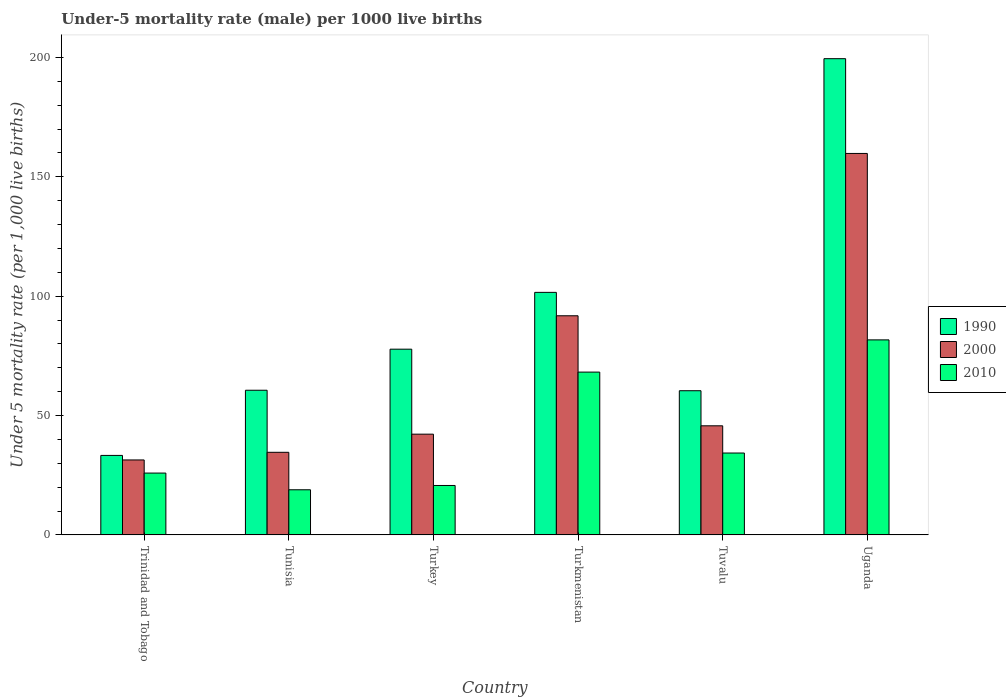How many bars are there on the 5th tick from the left?
Offer a terse response. 3. How many bars are there on the 6th tick from the right?
Provide a short and direct response. 3. What is the label of the 4th group of bars from the left?
Offer a terse response. Turkmenistan. What is the under-five mortality rate in 2000 in Tuvalu?
Give a very brief answer. 45.7. Across all countries, what is the maximum under-five mortality rate in 2010?
Your response must be concise. 81.7. Across all countries, what is the minimum under-five mortality rate in 2010?
Make the answer very short. 18.9. In which country was the under-five mortality rate in 2010 maximum?
Offer a very short reply. Uganda. In which country was the under-five mortality rate in 1990 minimum?
Your answer should be very brief. Trinidad and Tobago. What is the total under-five mortality rate in 2000 in the graph?
Offer a very short reply. 405.5. What is the difference between the under-five mortality rate in 1990 in Turkmenistan and that in Tuvalu?
Provide a short and direct response. 41.2. What is the difference between the under-five mortality rate in 2000 in Trinidad and Tobago and the under-five mortality rate in 1990 in Turkey?
Ensure brevity in your answer.  -46.4. What is the average under-five mortality rate in 2010 per country?
Provide a succinct answer. 41.62. What is the difference between the under-five mortality rate of/in 1990 and under-five mortality rate of/in 2000 in Uganda?
Provide a short and direct response. 39.7. What is the ratio of the under-five mortality rate in 2000 in Turkey to that in Tuvalu?
Your response must be concise. 0.92. Is the under-five mortality rate in 2000 in Tunisia less than that in Turkmenistan?
Your response must be concise. Yes. Is the difference between the under-five mortality rate in 1990 in Turkmenistan and Tuvalu greater than the difference between the under-five mortality rate in 2000 in Turkmenistan and Tuvalu?
Give a very brief answer. No. What is the difference between the highest and the second highest under-five mortality rate in 2000?
Make the answer very short. 46.1. What is the difference between the highest and the lowest under-five mortality rate in 2010?
Offer a terse response. 62.8. Is the sum of the under-five mortality rate in 2000 in Tuvalu and Uganda greater than the maximum under-five mortality rate in 1990 across all countries?
Offer a very short reply. Yes. What does the 1st bar from the right in Tunisia represents?
Ensure brevity in your answer.  2010. Are all the bars in the graph horizontal?
Keep it short and to the point. No. How many countries are there in the graph?
Give a very brief answer. 6. Does the graph contain any zero values?
Provide a succinct answer. No. How many legend labels are there?
Give a very brief answer. 3. What is the title of the graph?
Give a very brief answer. Under-5 mortality rate (male) per 1000 live births. What is the label or title of the X-axis?
Your answer should be very brief. Country. What is the label or title of the Y-axis?
Make the answer very short. Under 5 mortality rate (per 1,0 live births). What is the Under 5 mortality rate (per 1,000 live births) of 1990 in Trinidad and Tobago?
Keep it short and to the point. 33.3. What is the Under 5 mortality rate (per 1,000 live births) in 2000 in Trinidad and Tobago?
Make the answer very short. 31.4. What is the Under 5 mortality rate (per 1,000 live births) of 2010 in Trinidad and Tobago?
Your answer should be compact. 25.9. What is the Under 5 mortality rate (per 1,000 live births) of 1990 in Tunisia?
Your answer should be very brief. 60.6. What is the Under 5 mortality rate (per 1,000 live births) of 2000 in Tunisia?
Give a very brief answer. 34.6. What is the Under 5 mortality rate (per 1,000 live births) in 1990 in Turkey?
Make the answer very short. 77.8. What is the Under 5 mortality rate (per 1,000 live births) of 2000 in Turkey?
Ensure brevity in your answer.  42.2. What is the Under 5 mortality rate (per 1,000 live births) of 2010 in Turkey?
Your response must be concise. 20.7. What is the Under 5 mortality rate (per 1,000 live births) in 1990 in Turkmenistan?
Your answer should be very brief. 101.6. What is the Under 5 mortality rate (per 1,000 live births) in 2000 in Turkmenistan?
Make the answer very short. 91.8. What is the Under 5 mortality rate (per 1,000 live births) of 2010 in Turkmenistan?
Your response must be concise. 68.2. What is the Under 5 mortality rate (per 1,000 live births) in 1990 in Tuvalu?
Give a very brief answer. 60.4. What is the Under 5 mortality rate (per 1,000 live births) in 2000 in Tuvalu?
Your response must be concise. 45.7. What is the Under 5 mortality rate (per 1,000 live births) in 2010 in Tuvalu?
Your answer should be very brief. 34.3. What is the Under 5 mortality rate (per 1,000 live births) in 1990 in Uganda?
Your response must be concise. 199.5. What is the Under 5 mortality rate (per 1,000 live births) of 2000 in Uganda?
Make the answer very short. 159.8. What is the Under 5 mortality rate (per 1,000 live births) in 2010 in Uganda?
Provide a succinct answer. 81.7. Across all countries, what is the maximum Under 5 mortality rate (per 1,000 live births) of 1990?
Provide a short and direct response. 199.5. Across all countries, what is the maximum Under 5 mortality rate (per 1,000 live births) in 2000?
Offer a very short reply. 159.8. Across all countries, what is the maximum Under 5 mortality rate (per 1,000 live births) in 2010?
Provide a succinct answer. 81.7. Across all countries, what is the minimum Under 5 mortality rate (per 1,000 live births) in 1990?
Provide a succinct answer. 33.3. Across all countries, what is the minimum Under 5 mortality rate (per 1,000 live births) of 2000?
Make the answer very short. 31.4. What is the total Under 5 mortality rate (per 1,000 live births) of 1990 in the graph?
Your response must be concise. 533.2. What is the total Under 5 mortality rate (per 1,000 live births) of 2000 in the graph?
Provide a short and direct response. 405.5. What is the total Under 5 mortality rate (per 1,000 live births) in 2010 in the graph?
Ensure brevity in your answer.  249.7. What is the difference between the Under 5 mortality rate (per 1,000 live births) in 1990 in Trinidad and Tobago and that in Tunisia?
Offer a terse response. -27.3. What is the difference between the Under 5 mortality rate (per 1,000 live births) in 2000 in Trinidad and Tobago and that in Tunisia?
Give a very brief answer. -3.2. What is the difference between the Under 5 mortality rate (per 1,000 live births) of 1990 in Trinidad and Tobago and that in Turkey?
Your response must be concise. -44.5. What is the difference between the Under 5 mortality rate (per 1,000 live births) of 1990 in Trinidad and Tobago and that in Turkmenistan?
Your response must be concise. -68.3. What is the difference between the Under 5 mortality rate (per 1,000 live births) in 2000 in Trinidad and Tobago and that in Turkmenistan?
Ensure brevity in your answer.  -60.4. What is the difference between the Under 5 mortality rate (per 1,000 live births) of 2010 in Trinidad and Tobago and that in Turkmenistan?
Keep it short and to the point. -42.3. What is the difference between the Under 5 mortality rate (per 1,000 live births) in 1990 in Trinidad and Tobago and that in Tuvalu?
Provide a succinct answer. -27.1. What is the difference between the Under 5 mortality rate (per 1,000 live births) in 2000 in Trinidad and Tobago and that in Tuvalu?
Your response must be concise. -14.3. What is the difference between the Under 5 mortality rate (per 1,000 live births) in 2010 in Trinidad and Tobago and that in Tuvalu?
Your answer should be compact. -8.4. What is the difference between the Under 5 mortality rate (per 1,000 live births) of 1990 in Trinidad and Tobago and that in Uganda?
Make the answer very short. -166.2. What is the difference between the Under 5 mortality rate (per 1,000 live births) of 2000 in Trinidad and Tobago and that in Uganda?
Your answer should be very brief. -128.4. What is the difference between the Under 5 mortality rate (per 1,000 live births) of 2010 in Trinidad and Tobago and that in Uganda?
Provide a succinct answer. -55.8. What is the difference between the Under 5 mortality rate (per 1,000 live births) in 1990 in Tunisia and that in Turkey?
Your answer should be compact. -17.2. What is the difference between the Under 5 mortality rate (per 1,000 live births) of 2000 in Tunisia and that in Turkey?
Provide a short and direct response. -7.6. What is the difference between the Under 5 mortality rate (per 1,000 live births) in 2010 in Tunisia and that in Turkey?
Provide a succinct answer. -1.8. What is the difference between the Under 5 mortality rate (per 1,000 live births) of 1990 in Tunisia and that in Turkmenistan?
Provide a succinct answer. -41. What is the difference between the Under 5 mortality rate (per 1,000 live births) in 2000 in Tunisia and that in Turkmenistan?
Keep it short and to the point. -57.2. What is the difference between the Under 5 mortality rate (per 1,000 live births) of 2010 in Tunisia and that in Turkmenistan?
Provide a short and direct response. -49.3. What is the difference between the Under 5 mortality rate (per 1,000 live births) of 1990 in Tunisia and that in Tuvalu?
Offer a very short reply. 0.2. What is the difference between the Under 5 mortality rate (per 1,000 live births) of 2010 in Tunisia and that in Tuvalu?
Give a very brief answer. -15.4. What is the difference between the Under 5 mortality rate (per 1,000 live births) of 1990 in Tunisia and that in Uganda?
Your answer should be compact. -138.9. What is the difference between the Under 5 mortality rate (per 1,000 live births) of 2000 in Tunisia and that in Uganda?
Your answer should be very brief. -125.2. What is the difference between the Under 5 mortality rate (per 1,000 live births) in 2010 in Tunisia and that in Uganda?
Provide a succinct answer. -62.8. What is the difference between the Under 5 mortality rate (per 1,000 live births) of 1990 in Turkey and that in Turkmenistan?
Make the answer very short. -23.8. What is the difference between the Under 5 mortality rate (per 1,000 live births) in 2000 in Turkey and that in Turkmenistan?
Provide a succinct answer. -49.6. What is the difference between the Under 5 mortality rate (per 1,000 live births) of 2010 in Turkey and that in Turkmenistan?
Offer a very short reply. -47.5. What is the difference between the Under 5 mortality rate (per 1,000 live births) of 1990 in Turkey and that in Uganda?
Your answer should be very brief. -121.7. What is the difference between the Under 5 mortality rate (per 1,000 live births) of 2000 in Turkey and that in Uganda?
Your answer should be very brief. -117.6. What is the difference between the Under 5 mortality rate (per 1,000 live births) of 2010 in Turkey and that in Uganda?
Give a very brief answer. -61. What is the difference between the Under 5 mortality rate (per 1,000 live births) in 1990 in Turkmenistan and that in Tuvalu?
Ensure brevity in your answer.  41.2. What is the difference between the Under 5 mortality rate (per 1,000 live births) in 2000 in Turkmenistan and that in Tuvalu?
Your answer should be compact. 46.1. What is the difference between the Under 5 mortality rate (per 1,000 live births) in 2010 in Turkmenistan and that in Tuvalu?
Ensure brevity in your answer.  33.9. What is the difference between the Under 5 mortality rate (per 1,000 live births) of 1990 in Turkmenistan and that in Uganda?
Your response must be concise. -97.9. What is the difference between the Under 5 mortality rate (per 1,000 live births) of 2000 in Turkmenistan and that in Uganda?
Provide a succinct answer. -68. What is the difference between the Under 5 mortality rate (per 1,000 live births) of 1990 in Tuvalu and that in Uganda?
Provide a succinct answer. -139.1. What is the difference between the Under 5 mortality rate (per 1,000 live births) of 2000 in Tuvalu and that in Uganda?
Provide a short and direct response. -114.1. What is the difference between the Under 5 mortality rate (per 1,000 live births) of 2010 in Tuvalu and that in Uganda?
Offer a terse response. -47.4. What is the difference between the Under 5 mortality rate (per 1,000 live births) in 1990 in Trinidad and Tobago and the Under 5 mortality rate (per 1,000 live births) in 2010 in Tunisia?
Your answer should be very brief. 14.4. What is the difference between the Under 5 mortality rate (per 1,000 live births) of 1990 in Trinidad and Tobago and the Under 5 mortality rate (per 1,000 live births) of 2010 in Turkey?
Your response must be concise. 12.6. What is the difference between the Under 5 mortality rate (per 1,000 live births) of 2000 in Trinidad and Tobago and the Under 5 mortality rate (per 1,000 live births) of 2010 in Turkey?
Your answer should be compact. 10.7. What is the difference between the Under 5 mortality rate (per 1,000 live births) of 1990 in Trinidad and Tobago and the Under 5 mortality rate (per 1,000 live births) of 2000 in Turkmenistan?
Keep it short and to the point. -58.5. What is the difference between the Under 5 mortality rate (per 1,000 live births) in 1990 in Trinidad and Tobago and the Under 5 mortality rate (per 1,000 live births) in 2010 in Turkmenistan?
Your response must be concise. -34.9. What is the difference between the Under 5 mortality rate (per 1,000 live births) in 2000 in Trinidad and Tobago and the Under 5 mortality rate (per 1,000 live births) in 2010 in Turkmenistan?
Offer a very short reply. -36.8. What is the difference between the Under 5 mortality rate (per 1,000 live births) of 1990 in Trinidad and Tobago and the Under 5 mortality rate (per 1,000 live births) of 2000 in Tuvalu?
Offer a terse response. -12.4. What is the difference between the Under 5 mortality rate (per 1,000 live births) in 1990 in Trinidad and Tobago and the Under 5 mortality rate (per 1,000 live births) in 2010 in Tuvalu?
Offer a very short reply. -1. What is the difference between the Under 5 mortality rate (per 1,000 live births) in 1990 in Trinidad and Tobago and the Under 5 mortality rate (per 1,000 live births) in 2000 in Uganda?
Ensure brevity in your answer.  -126.5. What is the difference between the Under 5 mortality rate (per 1,000 live births) in 1990 in Trinidad and Tobago and the Under 5 mortality rate (per 1,000 live births) in 2010 in Uganda?
Ensure brevity in your answer.  -48.4. What is the difference between the Under 5 mortality rate (per 1,000 live births) of 2000 in Trinidad and Tobago and the Under 5 mortality rate (per 1,000 live births) of 2010 in Uganda?
Give a very brief answer. -50.3. What is the difference between the Under 5 mortality rate (per 1,000 live births) in 1990 in Tunisia and the Under 5 mortality rate (per 1,000 live births) in 2010 in Turkey?
Make the answer very short. 39.9. What is the difference between the Under 5 mortality rate (per 1,000 live births) in 1990 in Tunisia and the Under 5 mortality rate (per 1,000 live births) in 2000 in Turkmenistan?
Provide a short and direct response. -31.2. What is the difference between the Under 5 mortality rate (per 1,000 live births) of 1990 in Tunisia and the Under 5 mortality rate (per 1,000 live births) of 2010 in Turkmenistan?
Ensure brevity in your answer.  -7.6. What is the difference between the Under 5 mortality rate (per 1,000 live births) in 2000 in Tunisia and the Under 5 mortality rate (per 1,000 live births) in 2010 in Turkmenistan?
Offer a very short reply. -33.6. What is the difference between the Under 5 mortality rate (per 1,000 live births) in 1990 in Tunisia and the Under 5 mortality rate (per 1,000 live births) in 2010 in Tuvalu?
Ensure brevity in your answer.  26.3. What is the difference between the Under 5 mortality rate (per 1,000 live births) in 2000 in Tunisia and the Under 5 mortality rate (per 1,000 live births) in 2010 in Tuvalu?
Give a very brief answer. 0.3. What is the difference between the Under 5 mortality rate (per 1,000 live births) in 1990 in Tunisia and the Under 5 mortality rate (per 1,000 live births) in 2000 in Uganda?
Offer a terse response. -99.2. What is the difference between the Under 5 mortality rate (per 1,000 live births) of 1990 in Tunisia and the Under 5 mortality rate (per 1,000 live births) of 2010 in Uganda?
Provide a short and direct response. -21.1. What is the difference between the Under 5 mortality rate (per 1,000 live births) of 2000 in Tunisia and the Under 5 mortality rate (per 1,000 live births) of 2010 in Uganda?
Your answer should be compact. -47.1. What is the difference between the Under 5 mortality rate (per 1,000 live births) in 1990 in Turkey and the Under 5 mortality rate (per 1,000 live births) in 2000 in Turkmenistan?
Make the answer very short. -14. What is the difference between the Under 5 mortality rate (per 1,000 live births) in 2000 in Turkey and the Under 5 mortality rate (per 1,000 live births) in 2010 in Turkmenistan?
Your answer should be compact. -26. What is the difference between the Under 5 mortality rate (per 1,000 live births) of 1990 in Turkey and the Under 5 mortality rate (per 1,000 live births) of 2000 in Tuvalu?
Your answer should be compact. 32.1. What is the difference between the Under 5 mortality rate (per 1,000 live births) in 1990 in Turkey and the Under 5 mortality rate (per 1,000 live births) in 2010 in Tuvalu?
Give a very brief answer. 43.5. What is the difference between the Under 5 mortality rate (per 1,000 live births) of 2000 in Turkey and the Under 5 mortality rate (per 1,000 live births) of 2010 in Tuvalu?
Provide a succinct answer. 7.9. What is the difference between the Under 5 mortality rate (per 1,000 live births) in 1990 in Turkey and the Under 5 mortality rate (per 1,000 live births) in 2000 in Uganda?
Your answer should be compact. -82. What is the difference between the Under 5 mortality rate (per 1,000 live births) of 1990 in Turkey and the Under 5 mortality rate (per 1,000 live births) of 2010 in Uganda?
Offer a very short reply. -3.9. What is the difference between the Under 5 mortality rate (per 1,000 live births) of 2000 in Turkey and the Under 5 mortality rate (per 1,000 live births) of 2010 in Uganda?
Give a very brief answer. -39.5. What is the difference between the Under 5 mortality rate (per 1,000 live births) of 1990 in Turkmenistan and the Under 5 mortality rate (per 1,000 live births) of 2000 in Tuvalu?
Your answer should be very brief. 55.9. What is the difference between the Under 5 mortality rate (per 1,000 live births) of 1990 in Turkmenistan and the Under 5 mortality rate (per 1,000 live births) of 2010 in Tuvalu?
Provide a short and direct response. 67.3. What is the difference between the Under 5 mortality rate (per 1,000 live births) of 2000 in Turkmenistan and the Under 5 mortality rate (per 1,000 live births) of 2010 in Tuvalu?
Give a very brief answer. 57.5. What is the difference between the Under 5 mortality rate (per 1,000 live births) in 1990 in Turkmenistan and the Under 5 mortality rate (per 1,000 live births) in 2000 in Uganda?
Offer a terse response. -58.2. What is the difference between the Under 5 mortality rate (per 1,000 live births) of 1990 in Turkmenistan and the Under 5 mortality rate (per 1,000 live births) of 2010 in Uganda?
Offer a terse response. 19.9. What is the difference between the Under 5 mortality rate (per 1,000 live births) in 1990 in Tuvalu and the Under 5 mortality rate (per 1,000 live births) in 2000 in Uganda?
Keep it short and to the point. -99.4. What is the difference between the Under 5 mortality rate (per 1,000 live births) of 1990 in Tuvalu and the Under 5 mortality rate (per 1,000 live births) of 2010 in Uganda?
Your answer should be compact. -21.3. What is the difference between the Under 5 mortality rate (per 1,000 live births) of 2000 in Tuvalu and the Under 5 mortality rate (per 1,000 live births) of 2010 in Uganda?
Offer a terse response. -36. What is the average Under 5 mortality rate (per 1,000 live births) in 1990 per country?
Your answer should be compact. 88.87. What is the average Under 5 mortality rate (per 1,000 live births) of 2000 per country?
Offer a terse response. 67.58. What is the average Under 5 mortality rate (per 1,000 live births) of 2010 per country?
Keep it short and to the point. 41.62. What is the difference between the Under 5 mortality rate (per 1,000 live births) of 1990 and Under 5 mortality rate (per 1,000 live births) of 2000 in Tunisia?
Your answer should be very brief. 26. What is the difference between the Under 5 mortality rate (per 1,000 live births) in 1990 and Under 5 mortality rate (per 1,000 live births) in 2010 in Tunisia?
Your answer should be compact. 41.7. What is the difference between the Under 5 mortality rate (per 1,000 live births) of 1990 and Under 5 mortality rate (per 1,000 live births) of 2000 in Turkey?
Your answer should be very brief. 35.6. What is the difference between the Under 5 mortality rate (per 1,000 live births) in 1990 and Under 5 mortality rate (per 1,000 live births) in 2010 in Turkey?
Keep it short and to the point. 57.1. What is the difference between the Under 5 mortality rate (per 1,000 live births) of 1990 and Under 5 mortality rate (per 1,000 live births) of 2010 in Turkmenistan?
Your answer should be compact. 33.4. What is the difference between the Under 5 mortality rate (per 1,000 live births) in 2000 and Under 5 mortality rate (per 1,000 live births) in 2010 in Turkmenistan?
Your answer should be compact. 23.6. What is the difference between the Under 5 mortality rate (per 1,000 live births) of 1990 and Under 5 mortality rate (per 1,000 live births) of 2000 in Tuvalu?
Provide a short and direct response. 14.7. What is the difference between the Under 5 mortality rate (per 1,000 live births) of 1990 and Under 5 mortality rate (per 1,000 live births) of 2010 in Tuvalu?
Your answer should be very brief. 26.1. What is the difference between the Under 5 mortality rate (per 1,000 live births) in 1990 and Under 5 mortality rate (per 1,000 live births) in 2000 in Uganda?
Provide a short and direct response. 39.7. What is the difference between the Under 5 mortality rate (per 1,000 live births) in 1990 and Under 5 mortality rate (per 1,000 live births) in 2010 in Uganda?
Offer a very short reply. 117.8. What is the difference between the Under 5 mortality rate (per 1,000 live births) in 2000 and Under 5 mortality rate (per 1,000 live births) in 2010 in Uganda?
Provide a short and direct response. 78.1. What is the ratio of the Under 5 mortality rate (per 1,000 live births) in 1990 in Trinidad and Tobago to that in Tunisia?
Offer a terse response. 0.55. What is the ratio of the Under 5 mortality rate (per 1,000 live births) in 2000 in Trinidad and Tobago to that in Tunisia?
Ensure brevity in your answer.  0.91. What is the ratio of the Under 5 mortality rate (per 1,000 live births) of 2010 in Trinidad and Tobago to that in Tunisia?
Offer a very short reply. 1.37. What is the ratio of the Under 5 mortality rate (per 1,000 live births) in 1990 in Trinidad and Tobago to that in Turkey?
Offer a very short reply. 0.43. What is the ratio of the Under 5 mortality rate (per 1,000 live births) of 2000 in Trinidad and Tobago to that in Turkey?
Give a very brief answer. 0.74. What is the ratio of the Under 5 mortality rate (per 1,000 live births) of 2010 in Trinidad and Tobago to that in Turkey?
Provide a succinct answer. 1.25. What is the ratio of the Under 5 mortality rate (per 1,000 live births) in 1990 in Trinidad and Tobago to that in Turkmenistan?
Provide a short and direct response. 0.33. What is the ratio of the Under 5 mortality rate (per 1,000 live births) in 2000 in Trinidad and Tobago to that in Turkmenistan?
Provide a short and direct response. 0.34. What is the ratio of the Under 5 mortality rate (per 1,000 live births) of 2010 in Trinidad and Tobago to that in Turkmenistan?
Offer a terse response. 0.38. What is the ratio of the Under 5 mortality rate (per 1,000 live births) of 1990 in Trinidad and Tobago to that in Tuvalu?
Provide a short and direct response. 0.55. What is the ratio of the Under 5 mortality rate (per 1,000 live births) in 2000 in Trinidad and Tobago to that in Tuvalu?
Offer a very short reply. 0.69. What is the ratio of the Under 5 mortality rate (per 1,000 live births) in 2010 in Trinidad and Tobago to that in Tuvalu?
Offer a terse response. 0.76. What is the ratio of the Under 5 mortality rate (per 1,000 live births) of 1990 in Trinidad and Tobago to that in Uganda?
Give a very brief answer. 0.17. What is the ratio of the Under 5 mortality rate (per 1,000 live births) of 2000 in Trinidad and Tobago to that in Uganda?
Ensure brevity in your answer.  0.2. What is the ratio of the Under 5 mortality rate (per 1,000 live births) of 2010 in Trinidad and Tobago to that in Uganda?
Give a very brief answer. 0.32. What is the ratio of the Under 5 mortality rate (per 1,000 live births) in 1990 in Tunisia to that in Turkey?
Your answer should be very brief. 0.78. What is the ratio of the Under 5 mortality rate (per 1,000 live births) of 2000 in Tunisia to that in Turkey?
Keep it short and to the point. 0.82. What is the ratio of the Under 5 mortality rate (per 1,000 live births) in 1990 in Tunisia to that in Turkmenistan?
Provide a succinct answer. 0.6. What is the ratio of the Under 5 mortality rate (per 1,000 live births) in 2000 in Tunisia to that in Turkmenistan?
Ensure brevity in your answer.  0.38. What is the ratio of the Under 5 mortality rate (per 1,000 live births) of 2010 in Tunisia to that in Turkmenistan?
Offer a terse response. 0.28. What is the ratio of the Under 5 mortality rate (per 1,000 live births) of 2000 in Tunisia to that in Tuvalu?
Offer a very short reply. 0.76. What is the ratio of the Under 5 mortality rate (per 1,000 live births) in 2010 in Tunisia to that in Tuvalu?
Your answer should be compact. 0.55. What is the ratio of the Under 5 mortality rate (per 1,000 live births) in 1990 in Tunisia to that in Uganda?
Keep it short and to the point. 0.3. What is the ratio of the Under 5 mortality rate (per 1,000 live births) in 2000 in Tunisia to that in Uganda?
Offer a very short reply. 0.22. What is the ratio of the Under 5 mortality rate (per 1,000 live births) of 2010 in Tunisia to that in Uganda?
Your answer should be compact. 0.23. What is the ratio of the Under 5 mortality rate (per 1,000 live births) of 1990 in Turkey to that in Turkmenistan?
Provide a short and direct response. 0.77. What is the ratio of the Under 5 mortality rate (per 1,000 live births) in 2000 in Turkey to that in Turkmenistan?
Your answer should be very brief. 0.46. What is the ratio of the Under 5 mortality rate (per 1,000 live births) of 2010 in Turkey to that in Turkmenistan?
Provide a short and direct response. 0.3. What is the ratio of the Under 5 mortality rate (per 1,000 live births) in 1990 in Turkey to that in Tuvalu?
Your response must be concise. 1.29. What is the ratio of the Under 5 mortality rate (per 1,000 live births) in 2000 in Turkey to that in Tuvalu?
Keep it short and to the point. 0.92. What is the ratio of the Under 5 mortality rate (per 1,000 live births) in 2010 in Turkey to that in Tuvalu?
Your answer should be very brief. 0.6. What is the ratio of the Under 5 mortality rate (per 1,000 live births) of 1990 in Turkey to that in Uganda?
Give a very brief answer. 0.39. What is the ratio of the Under 5 mortality rate (per 1,000 live births) in 2000 in Turkey to that in Uganda?
Keep it short and to the point. 0.26. What is the ratio of the Under 5 mortality rate (per 1,000 live births) of 2010 in Turkey to that in Uganda?
Provide a succinct answer. 0.25. What is the ratio of the Under 5 mortality rate (per 1,000 live births) in 1990 in Turkmenistan to that in Tuvalu?
Keep it short and to the point. 1.68. What is the ratio of the Under 5 mortality rate (per 1,000 live births) of 2000 in Turkmenistan to that in Tuvalu?
Your answer should be very brief. 2.01. What is the ratio of the Under 5 mortality rate (per 1,000 live births) of 2010 in Turkmenistan to that in Tuvalu?
Give a very brief answer. 1.99. What is the ratio of the Under 5 mortality rate (per 1,000 live births) of 1990 in Turkmenistan to that in Uganda?
Make the answer very short. 0.51. What is the ratio of the Under 5 mortality rate (per 1,000 live births) in 2000 in Turkmenistan to that in Uganda?
Provide a succinct answer. 0.57. What is the ratio of the Under 5 mortality rate (per 1,000 live births) in 2010 in Turkmenistan to that in Uganda?
Your answer should be compact. 0.83. What is the ratio of the Under 5 mortality rate (per 1,000 live births) of 1990 in Tuvalu to that in Uganda?
Give a very brief answer. 0.3. What is the ratio of the Under 5 mortality rate (per 1,000 live births) in 2000 in Tuvalu to that in Uganda?
Your answer should be very brief. 0.29. What is the ratio of the Under 5 mortality rate (per 1,000 live births) of 2010 in Tuvalu to that in Uganda?
Make the answer very short. 0.42. What is the difference between the highest and the second highest Under 5 mortality rate (per 1,000 live births) in 1990?
Your response must be concise. 97.9. What is the difference between the highest and the second highest Under 5 mortality rate (per 1,000 live births) in 2000?
Your answer should be very brief. 68. What is the difference between the highest and the lowest Under 5 mortality rate (per 1,000 live births) in 1990?
Your answer should be very brief. 166.2. What is the difference between the highest and the lowest Under 5 mortality rate (per 1,000 live births) of 2000?
Keep it short and to the point. 128.4. What is the difference between the highest and the lowest Under 5 mortality rate (per 1,000 live births) in 2010?
Offer a terse response. 62.8. 